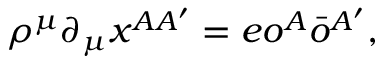<formula> <loc_0><loc_0><loc_500><loc_500>\rho ^ { \mu } \partial _ { \mu } x ^ { A A ^ { \prime } } = e o ^ { A } \bar { o } ^ { A ^ { \prime } } ,</formula> 